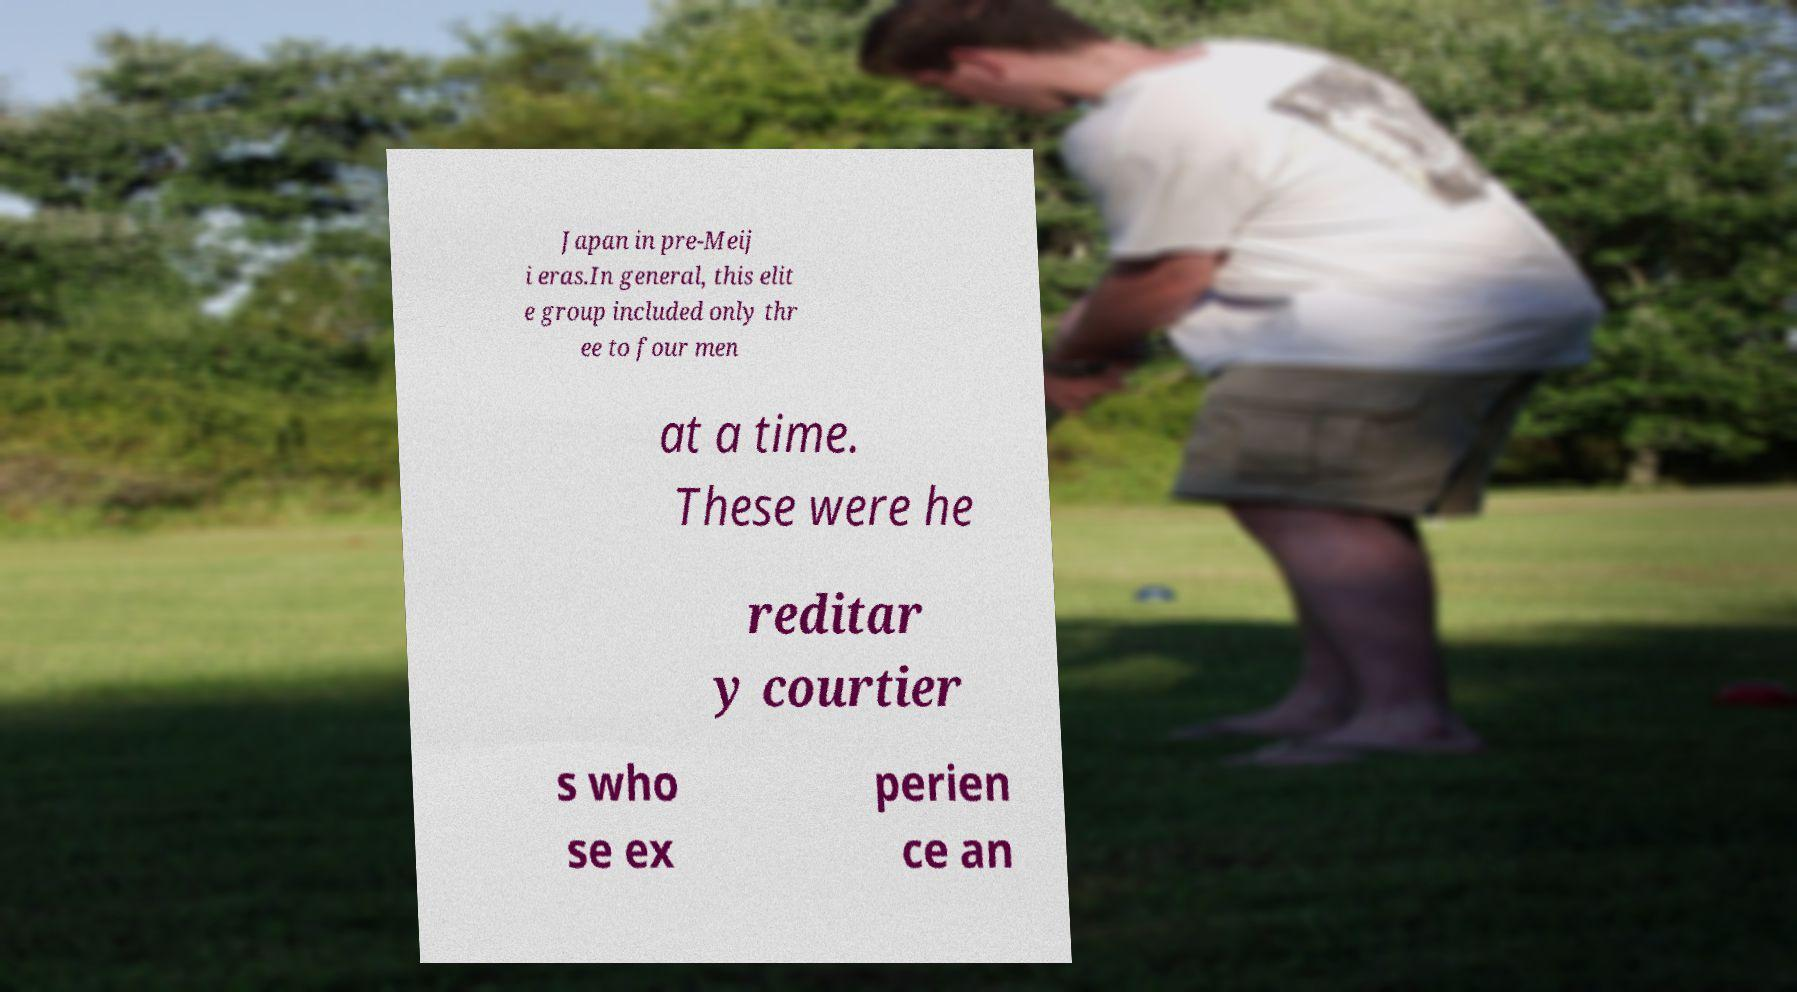Please read and relay the text visible in this image. What does it say? Japan in pre-Meij i eras.In general, this elit e group included only thr ee to four men at a time. These were he reditar y courtier s who se ex perien ce an 